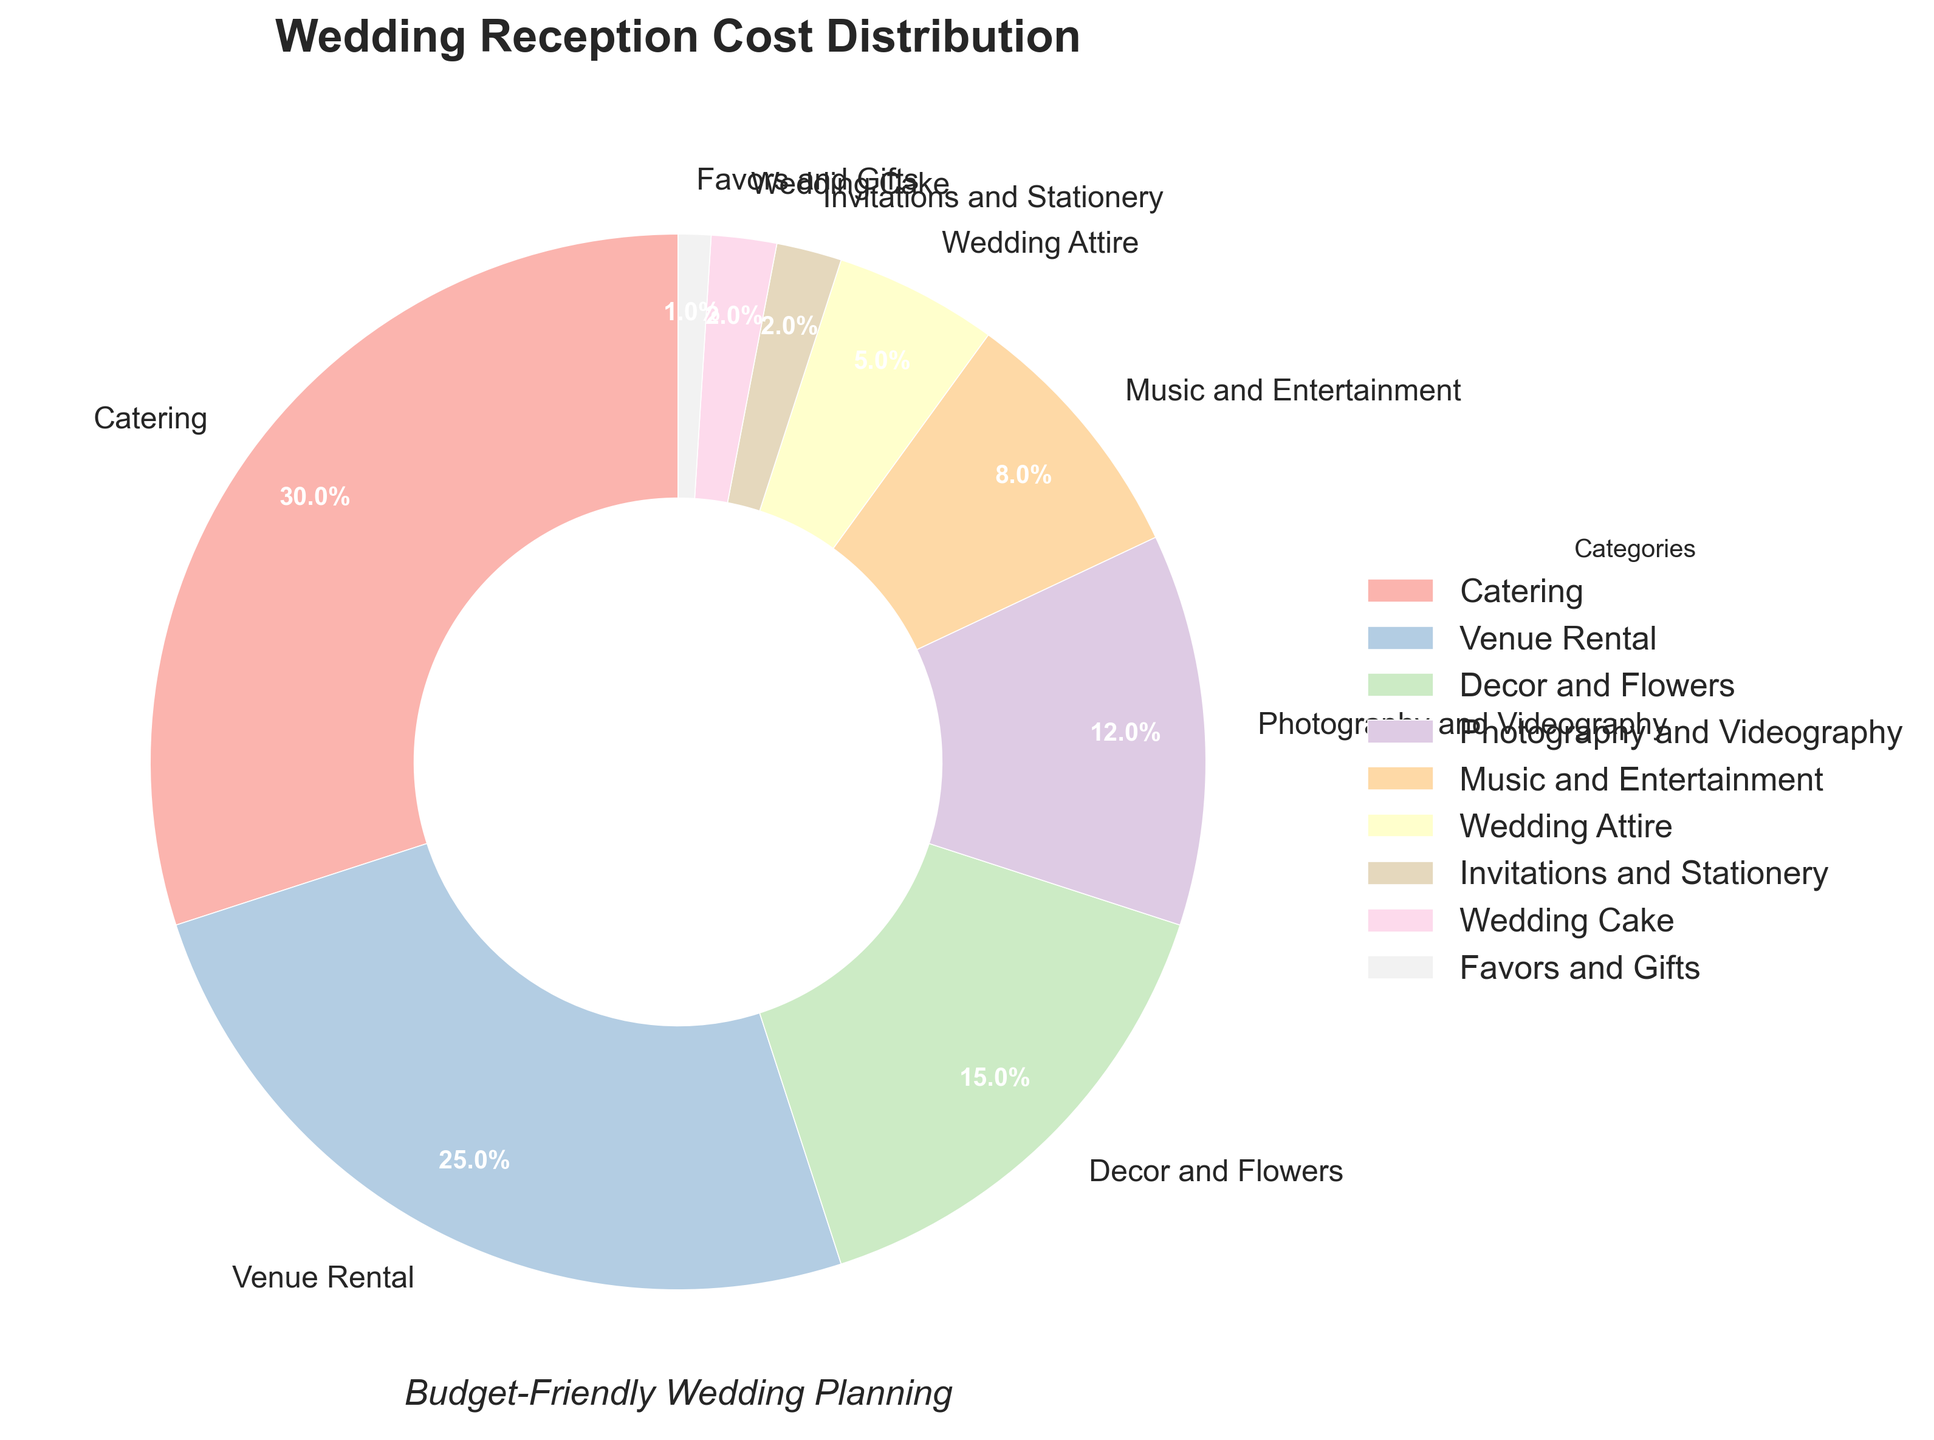What is the largest category in terms of percentage? The category with the largest percentage is the one taking up the most space in the pie chart.
Answer: Catering Which two categories combined account for more than 50% of the costs? Add the percentages of the two largest slices and see if their sum exceeds 50%. Catering (30%) and Venue Rental (25%) together are 30% + 25% = 55%.
Answer: Catering and Venue Rental How much more does Music and Entertainment cost compared to Wedding Cake? Subtract the smaller percentage (Wedding Cake: 2%) from the larger one (Music and Entertainment: 8%).
Answer: 6% What is the total percentage of costs for categories listed as less than 5% each? Add the percentages of categories with less than 5%: Wedding Attire (5%), Invitations and Stationery (2%), Wedding Cake (2%), and Favors and Gifts (1%). 2% + 2% + 1% = 5%.
Answer: 5% Which category is the smallest slice in the pie chart? The smallest slice corresponds to the category with the lowest percentage.
Answer: Favors and Gifts Compare the combined costs of Decor and Flowers and Photography and Videography to the cost of Catering. Which is higher, and by how much? Calculate the combined costs (Decor and Flowers: 15%, Photography and Videography: 12%) and compare it to Catering (30%). 15% + 12% = 27%, so Catering is higher by 3%.
Answer: Catering by 3% What portion of the pie chart is represented by categories related to appearance (Decor and Flowers, Wedding Attire)? Add the percentages of Decor and Flowers (15%) and Wedding Attire (5%).
Answer: 20% What is the difference in cost between Venue Rental and Photography and Videography? Subtract the percentage of Photography and Videography (12%) from Venue Rental (25%).
Answer: 13% Which category takes up more space on the chart, Invitations and Stationery, or Wedding Cake? Compare the percentages of Invitations and Stationery (2%) and Wedding Cake (2%). They are equal.
Answer: Equal 